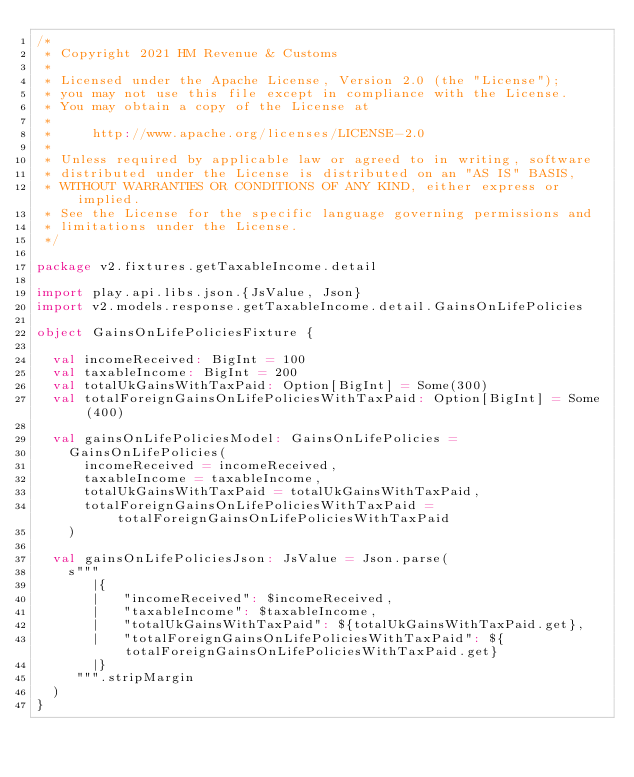<code> <loc_0><loc_0><loc_500><loc_500><_Scala_>/*
 * Copyright 2021 HM Revenue & Customs
 *
 * Licensed under the Apache License, Version 2.0 (the "License");
 * you may not use this file except in compliance with the License.
 * You may obtain a copy of the License at
 *
 *     http://www.apache.org/licenses/LICENSE-2.0
 *
 * Unless required by applicable law or agreed to in writing, software
 * distributed under the License is distributed on an "AS IS" BASIS,
 * WITHOUT WARRANTIES OR CONDITIONS OF ANY KIND, either express or implied.
 * See the License for the specific language governing permissions and
 * limitations under the License.
 */

package v2.fixtures.getTaxableIncome.detail

import play.api.libs.json.{JsValue, Json}
import v2.models.response.getTaxableIncome.detail.GainsOnLifePolicies

object GainsOnLifePoliciesFixture {

  val incomeReceived: BigInt = 100
  val taxableIncome: BigInt = 200
  val totalUkGainsWithTaxPaid: Option[BigInt] = Some(300)
  val totalForeignGainsOnLifePoliciesWithTaxPaid: Option[BigInt] = Some(400)

  val gainsOnLifePoliciesModel: GainsOnLifePolicies =
    GainsOnLifePolicies(
      incomeReceived = incomeReceived,
      taxableIncome = taxableIncome,
      totalUkGainsWithTaxPaid = totalUkGainsWithTaxPaid,
      totalForeignGainsOnLifePoliciesWithTaxPaid = totalForeignGainsOnLifePoliciesWithTaxPaid
    )

  val gainsOnLifePoliciesJson: JsValue = Json.parse(
    s"""
       |{
       |   "incomeReceived": $incomeReceived,
       |   "taxableIncome": $taxableIncome,
       |   "totalUkGainsWithTaxPaid": ${totalUkGainsWithTaxPaid.get},
       |   "totalForeignGainsOnLifePoliciesWithTaxPaid": ${totalForeignGainsOnLifePoliciesWithTaxPaid.get}
       |}
     """.stripMargin
  )
}</code> 